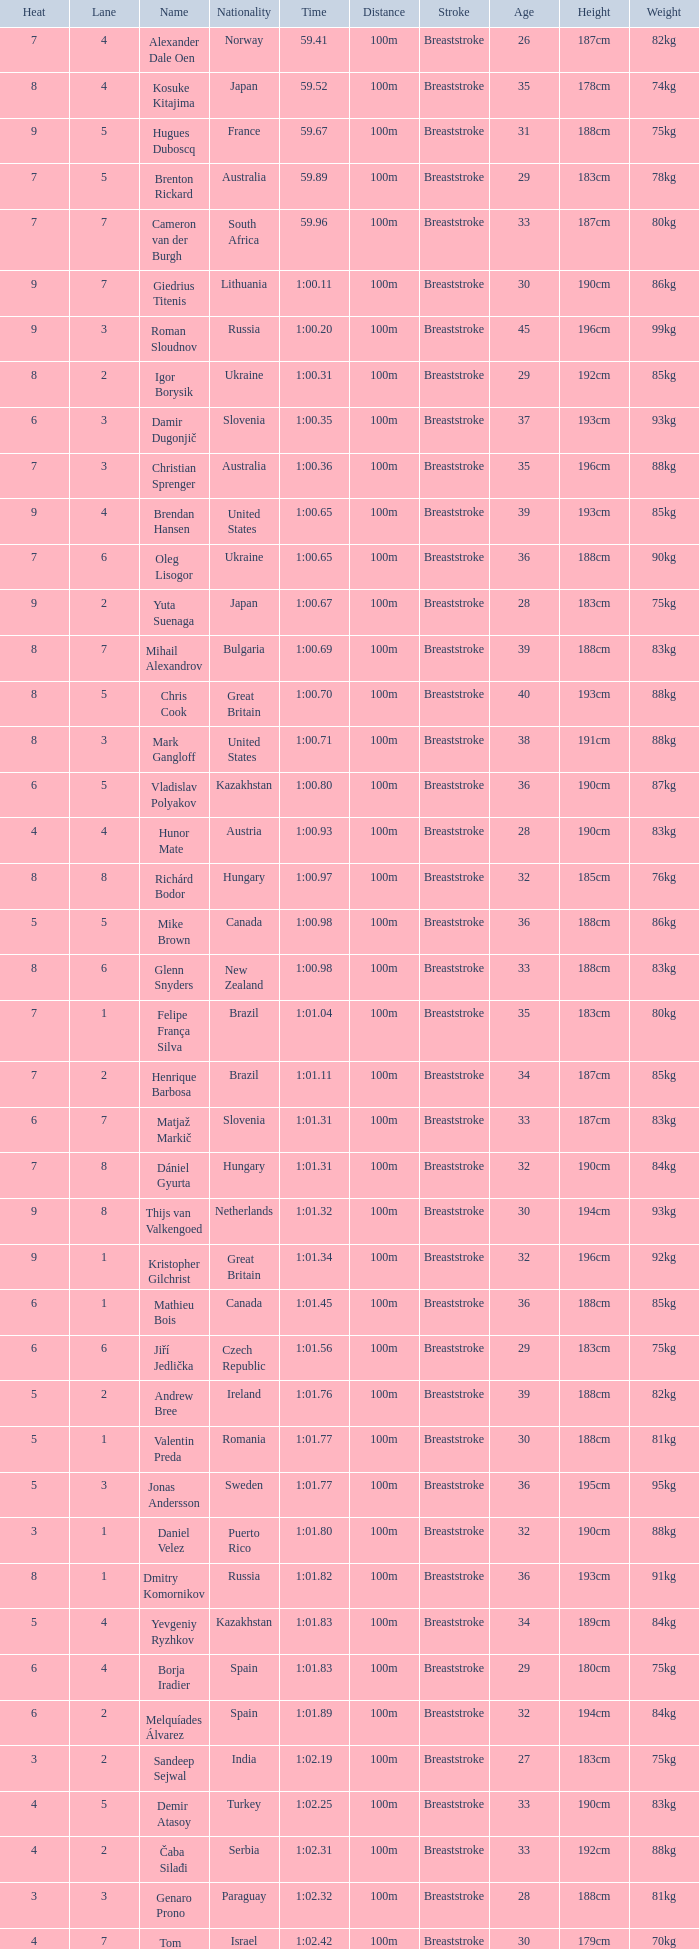What is the time in a heat smaller than 5, in Lane 5, for Vietnam? 1:06.36. 